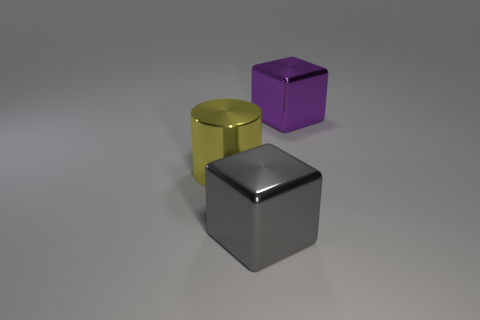Which object appears to be in the foreground and why? The gray cube appears to be in the foreground because it is the largest in the frame and centrally positioned, making it appear closer to the viewer than the other objects. Do the objects cast any shadows or reflections? Yes, each object casts a soft shadow directly beneath it, and there are subtle reflections on the surface, indicating it is smooth and possibly reflective. 